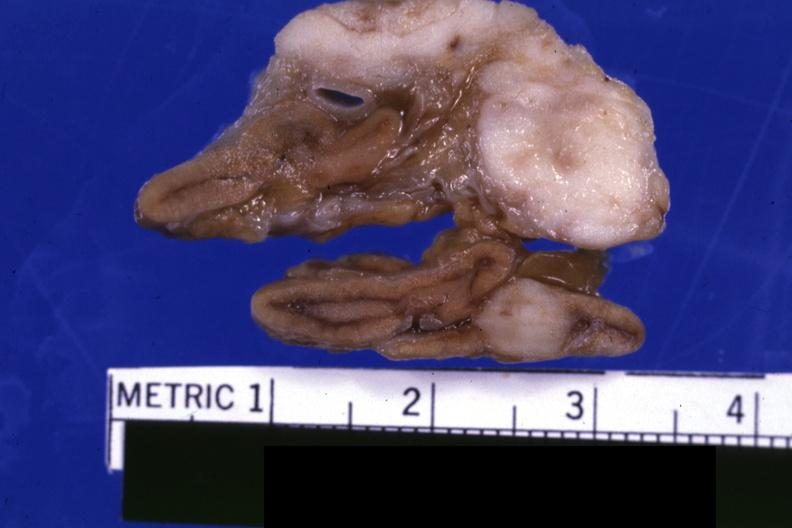does this image show fixed tissue close-up excellent except for color?
Answer the question using a single word or phrase. Yes 